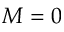<formula> <loc_0><loc_0><loc_500><loc_500>M = 0</formula> 